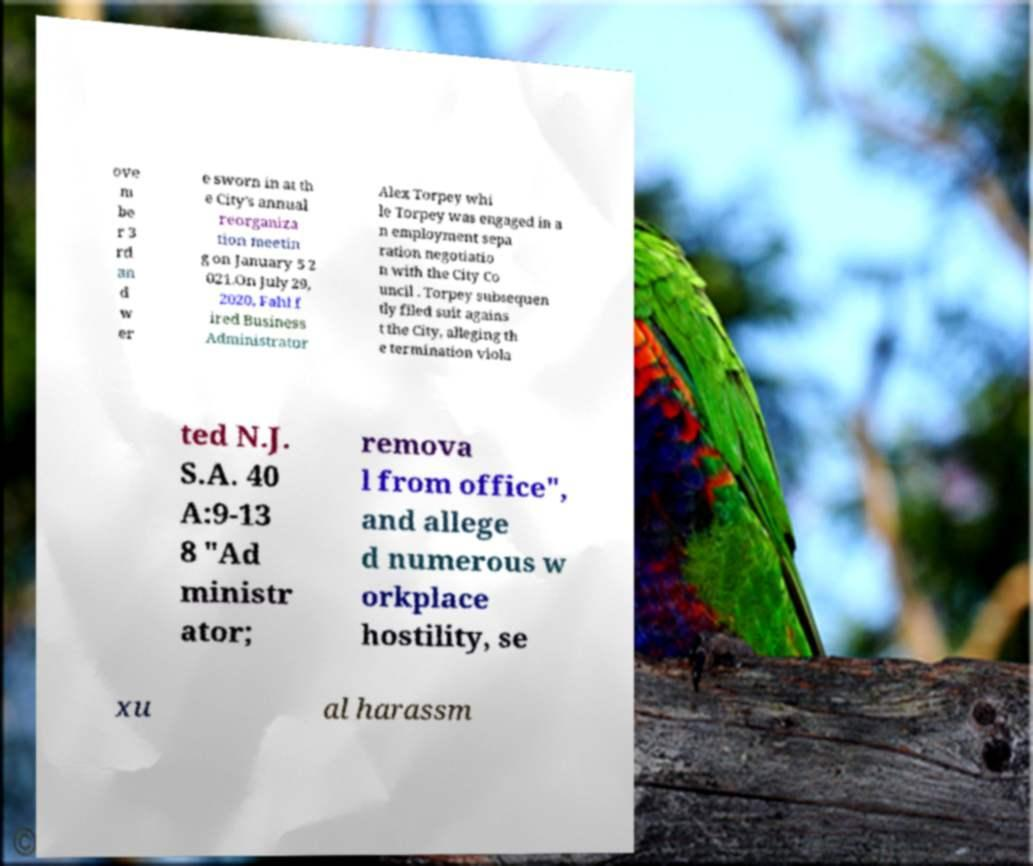Please read and relay the text visible in this image. What does it say? ove m be r 3 rd an d w er e sworn in at th e City's annual reorganiza tion meetin g on January 5 2 021.On July 29, 2020, Fahl f ired Business Administrator Alex Torpey whi le Torpey was engaged in a n employment sepa ration negotiatio n with the City Co uncil . Torpey subsequen tly filed suit agains t the City, alleging th e termination viola ted N.J. S.A. 40 A:9-13 8 "Ad ministr ator; remova l from office", and allege d numerous w orkplace hostility, se xu al harassm 